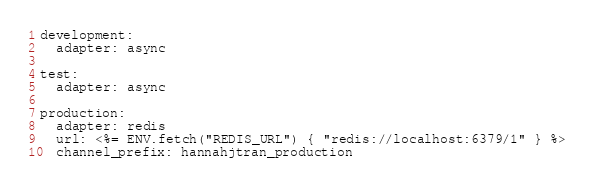<code> <loc_0><loc_0><loc_500><loc_500><_YAML_>development:
  adapter: async

test:
  adapter: async

production:
  adapter: redis
  url: <%= ENV.fetch("REDIS_URL") { "redis://localhost:6379/1" } %>
  channel_prefix: hannahjtran_production
</code> 